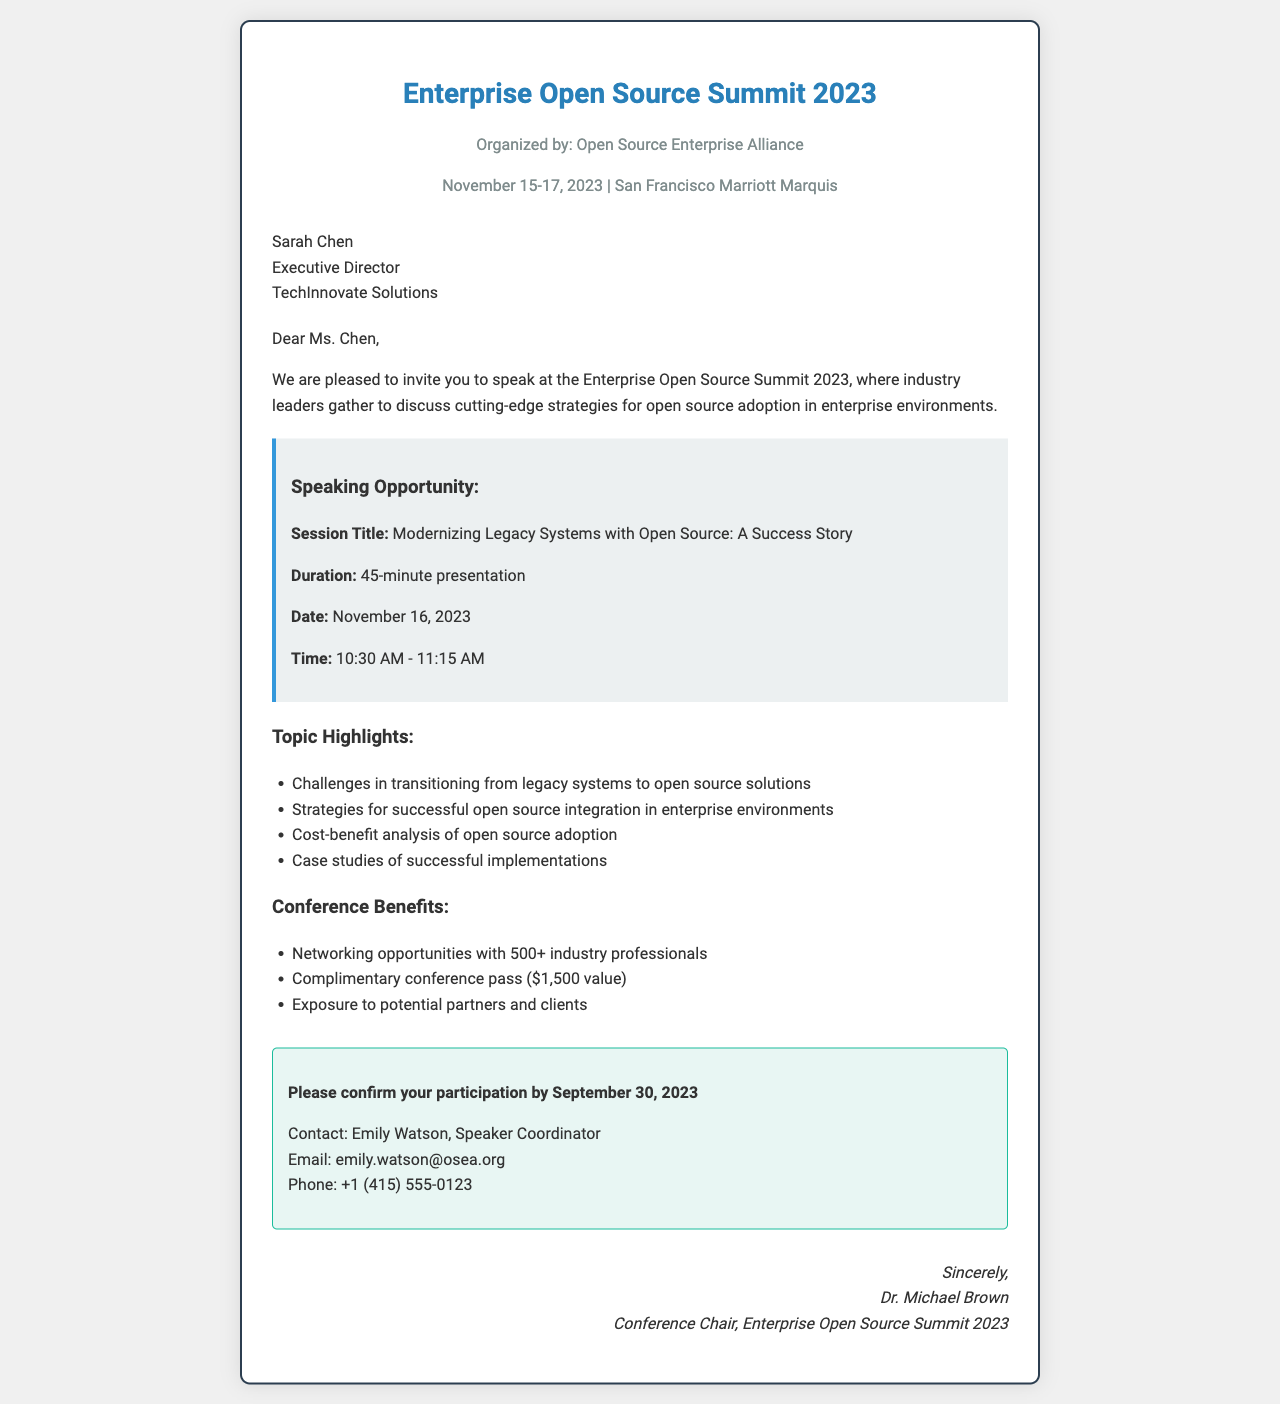What is the name of the conference? The name of the conference is stated in the document as "Enterprise Open Source Summit 2023."
Answer: Enterprise Open Source Summit 2023 Who is the recipient of the invitation? The document specifies Sarah Chen as the recipient of the invitation.
Answer: Sarah Chen What is the date of the speaking session? The document clearly mentions the date of the speaking session as November 16, 2023.
Answer: November 16, 2023 How long is the presentation? The document indicates the duration of the presentation as 45 minutes.
Answer: 45-minute What is the contact person’s name for confirmation? Emily Watson is the named contact person for confirming participation in the document.
Answer: Emily Watson What are the benefits of attending the conference? The document lists multiple benefits including networking opportunities, a complimentary conference pass, and exposure to potential partners. This requires reasoning.
Answer: Networking opportunities, complimentary conference pass, exposure to potential partners When is the confirmation deadline? The document states that the confirmation for participation must be done by September 30, 2023.
Answer: September 30, 2023 What is the session title? The title of the session is directly mentioned in the document as "Modernizing Legacy Systems with Open Source: A Success Story."
Answer: Modernizing Legacy Systems with Open Source: A Success Story What is the email address of the contact person? The document provides Emily Watson's email address as emily.watson@osea.org.
Answer: emily.watson@osea.org Where is the conference being held? The document specifies that the conference is at San Francisco Marriott Marquis.
Answer: San Francisco Marriott Marquis 